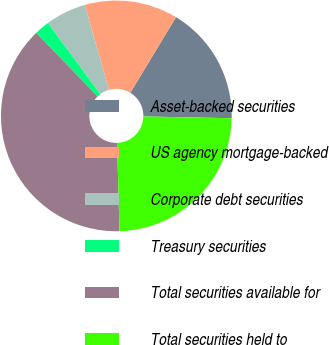<chart> <loc_0><loc_0><loc_500><loc_500><pie_chart><fcel>Asset-backed securities<fcel>US agency mortgage-backed<fcel>Corporate debt securities<fcel>Treasury securities<fcel>Total securities available for<fcel>Total securities held to<nl><fcel>16.67%<fcel>13.06%<fcel>5.7%<fcel>2.09%<fcel>38.23%<fcel>24.24%<nl></chart> 